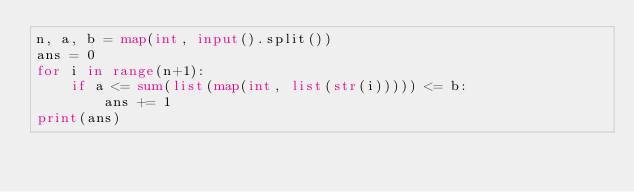Convert code to text. <code><loc_0><loc_0><loc_500><loc_500><_Python_>n, a, b = map(int, input().split())
ans = 0
for i in range(n+1):
    if a <= sum(list(map(int, list(str(i))))) <= b:
        ans += 1
print(ans)</code> 